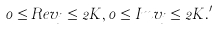<formula> <loc_0><loc_0><loc_500><loc_500>0 \leq R e v _ { j } \leq 2 K , 0 \leq I m v _ { j } \leq 2 K . ^ { \prime }</formula> 